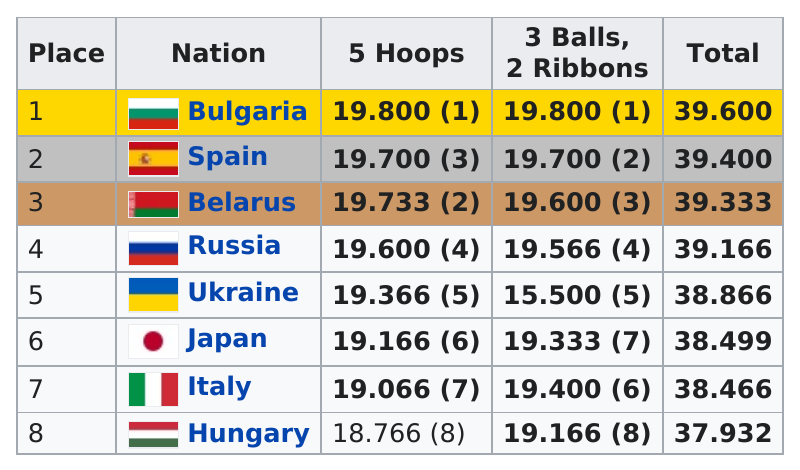Give some essential details in this illustration. The two nations, Bulgaria and Spain, scored the same for 5 hoops and 3 balls, as well as 2 ribbons. Russia has faced defeat from countries other than Spain, with Belarus being one such example. Seven teams scored 19.000 or greater in the 5 hoops competition. Bulgaria was the top scoring nation in the games. The nation of Hungary placed last in the competition. 